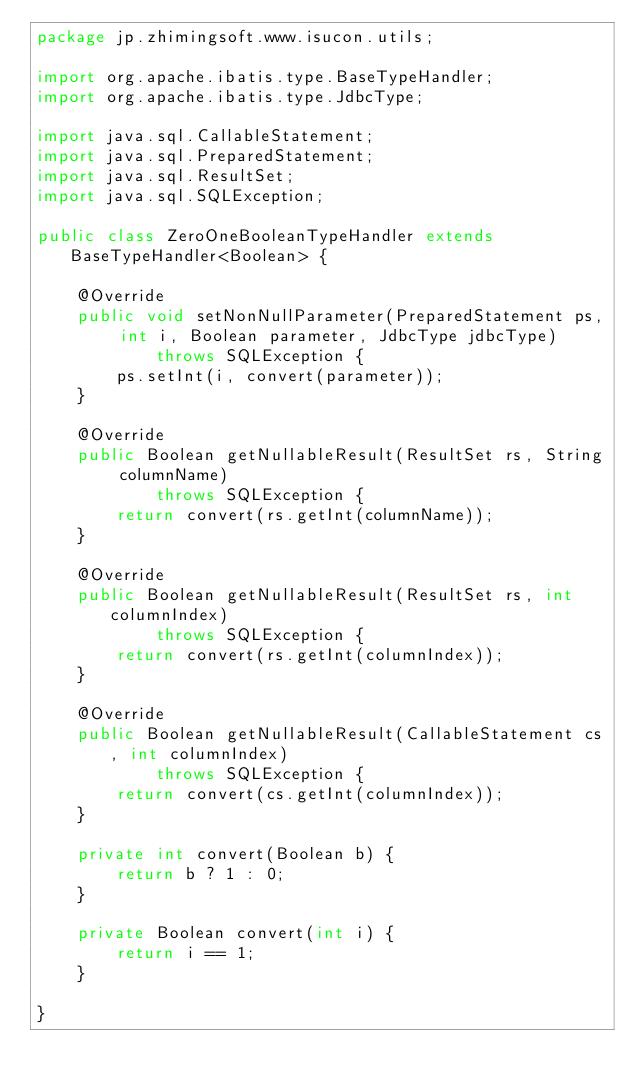<code> <loc_0><loc_0><loc_500><loc_500><_Java_>package jp.zhimingsoft.www.isucon.utils;

import org.apache.ibatis.type.BaseTypeHandler;
import org.apache.ibatis.type.JdbcType;

import java.sql.CallableStatement;
import java.sql.PreparedStatement;
import java.sql.ResultSet;
import java.sql.SQLException;

public class ZeroOneBooleanTypeHandler extends BaseTypeHandler<Boolean> {

    @Override
    public void setNonNullParameter(PreparedStatement ps, int i, Boolean parameter, JdbcType jdbcType)
            throws SQLException {
        ps.setInt(i, convert(parameter));
    }

    @Override
    public Boolean getNullableResult(ResultSet rs, String columnName)
            throws SQLException {
        return convert(rs.getInt(columnName));
    }

    @Override
    public Boolean getNullableResult(ResultSet rs, int columnIndex)
            throws SQLException {
        return convert(rs.getInt(columnIndex));
    }

    @Override
    public Boolean getNullableResult(CallableStatement cs, int columnIndex)
            throws SQLException {
        return convert(cs.getInt(columnIndex));
    }

    private int convert(Boolean b) {
        return b ? 1 : 0;
    }

    private Boolean convert(int i) {
        return i == 1;
    }

}</code> 